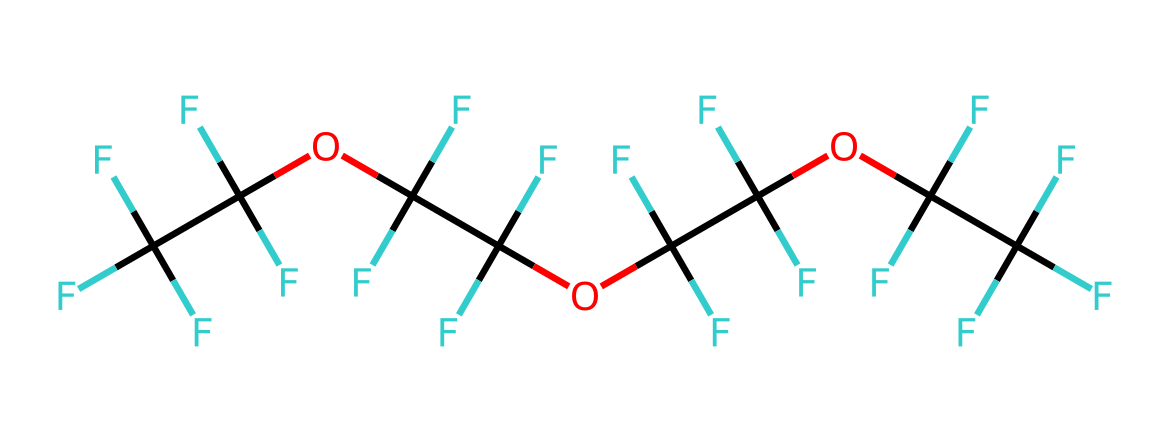What is the primary element in this chemical? The SMILES representation indicates the presence of carbon and fluorine atoms. By counting, there are more carbon (C) atoms than any other. The specific number reveals the predominant presence of carbon.
Answer: carbon How many fluorine atoms are present? By analyzing the SMILES representation, fluorine (F) atoms can be directly counted. The structure shows numerous instances of "F," allowing for an accurate total count. The count indicates that there are twelve fluorine atoms in total.
Answer: twelve What type of functional groups are present? The structure reveals multiple ether linkages due to the “OC” fragments, which indicates that ether functional groups are present throughout the compound. This indicates the chemical's ability to function as a lubricant with low viscosity and high stability.
Answer: ether Does this chemical contain any oxygen atoms? An examination of the SMILES representation for the oxygen "O" within the structure confirms its presence. In the structure, there are five instances of "O," confirming multiple oxygen atoms are present in this chemical.
Answer: five Is this compound polar or non-polar? The presence of numerous fluorine atoms, which are highly electronegative, along with the ways they interact with carbon influences the overall polarity. In combination with the carbon atoms, this structure is highly non-polar due to the dominating fluorinated environment.
Answer: non-polar What is the likely state of this chemical at room temperature? The substantial presence of fluorinated groups and the molecular composition implies a low viscosity liquid. Such compounds typically exist as viscous liquids or can be waxy solids at standard conditions.
Answer: liquid 